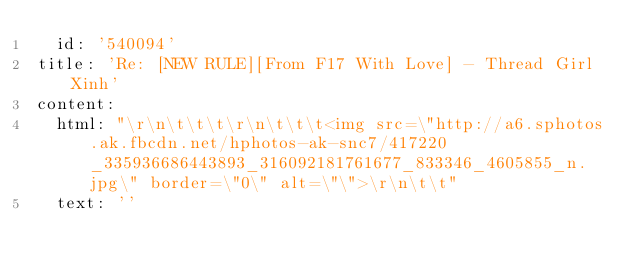<code> <loc_0><loc_0><loc_500><loc_500><_YAML_>  id: '540094'
title: 'Re: [NEW RULE][From F17 With Love] - Thread Girl Xinh'
content:
  html: "\r\n\t\t\t\r\n\t\t\t<img src=\"http://a6.sphotos.ak.fbcdn.net/hphotos-ak-snc7/417220_335936686443893_316092181761677_833346_4605855_n.jpg\" border=\"0\" alt=\"\">\r\n\t\t"
  text: ''
</code> 